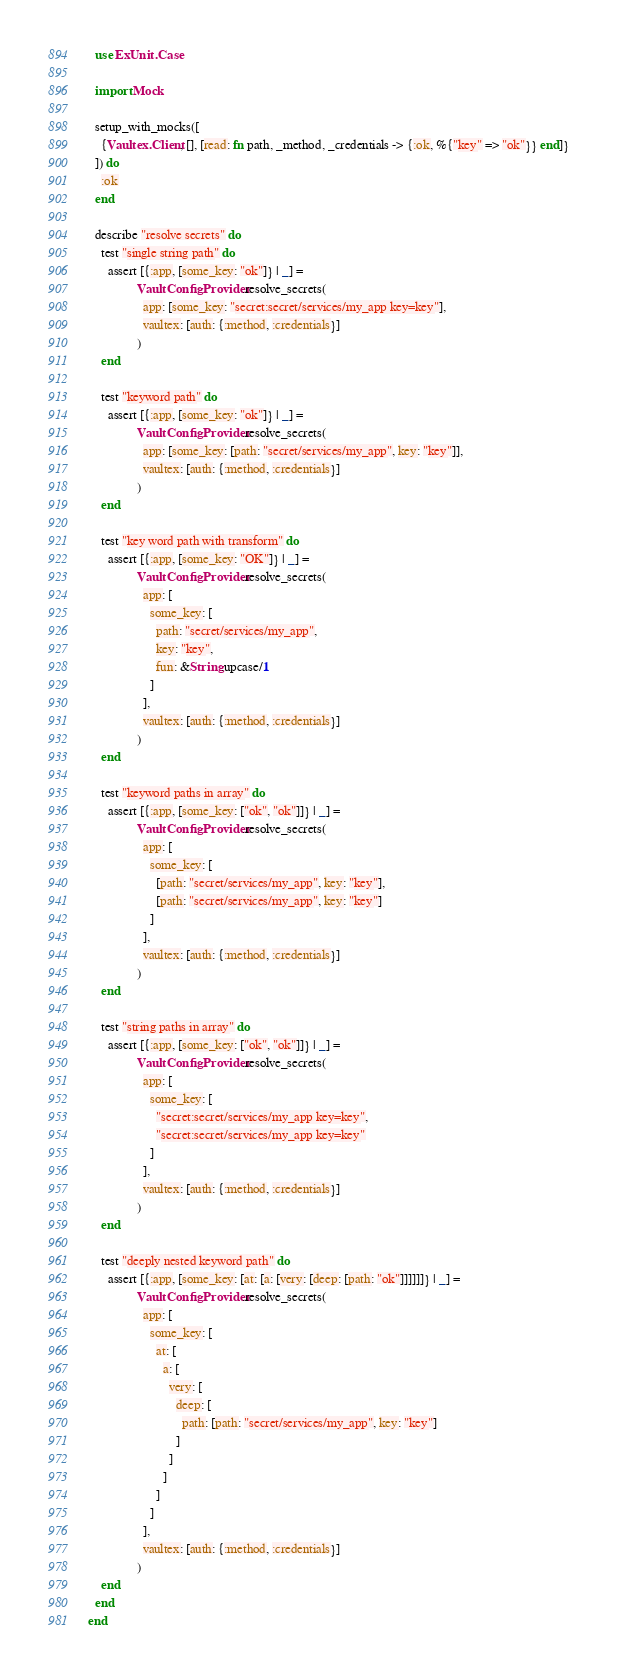<code> <loc_0><loc_0><loc_500><loc_500><_Elixir_>  use ExUnit.Case

  import Mock

  setup_with_mocks([
    {Vaultex.Client, [], [read: fn path, _method, _credentials -> {:ok, %{"key" => "ok"}} end]}
  ]) do
    :ok
  end

  describe "resolve secrets" do
    test "single string path" do
      assert [{:app, [some_key: "ok"]} | _] =
               VaultConfigProvider.resolve_secrets(
                 app: [some_key: "secret:secret/services/my_app key=key"],
                 vaultex: [auth: {:method, :credentials}]
               )
    end

    test "keyword path" do
      assert [{:app, [some_key: "ok"]} | _] =
               VaultConfigProvider.resolve_secrets(
                 app: [some_key: [path: "secret/services/my_app", key: "key"]],
                 vaultex: [auth: {:method, :credentials}]
               )
    end

    test "key word path with transform" do
      assert [{:app, [some_key: "OK"]} | _] =
               VaultConfigProvider.resolve_secrets(
                 app: [
                   some_key: [
                     path: "secret/services/my_app",
                     key: "key",
                     fun: &String.upcase/1
                   ]
                 ],
                 vaultex: [auth: {:method, :credentials}]
               )
    end

    test "keyword paths in array" do
      assert [{:app, [some_key: ["ok", "ok"]]} | _] =
               VaultConfigProvider.resolve_secrets(
                 app: [
                   some_key: [
                     [path: "secret/services/my_app", key: "key"],
                     [path: "secret/services/my_app", key: "key"]
                   ]
                 ],
                 vaultex: [auth: {:method, :credentials}]
               )
    end

    test "string paths in array" do
      assert [{:app, [some_key: ["ok", "ok"]]} | _] =
               VaultConfigProvider.resolve_secrets(
                 app: [
                   some_key: [
                     "secret:secret/services/my_app key=key",
                     "secret:secret/services/my_app key=key"
                   ]
                 ],
                 vaultex: [auth: {:method, :credentials}]
               )
    end

    test "deeply nested keyword path" do
      assert [{:app, [some_key: [at: [a: [very: [deep: [path: "ok"]]]]]]} | _] =
               VaultConfigProvider.resolve_secrets(
                 app: [
                   some_key: [
                     at: [
                       a: [
                         very: [
                           deep: [
                             path: [path: "secret/services/my_app", key: "key"]
                           ]
                         ]
                       ]
                     ]
                   ]
                 ],
                 vaultex: [auth: {:method, :credentials}]
               )
    end
  end
end
</code> 